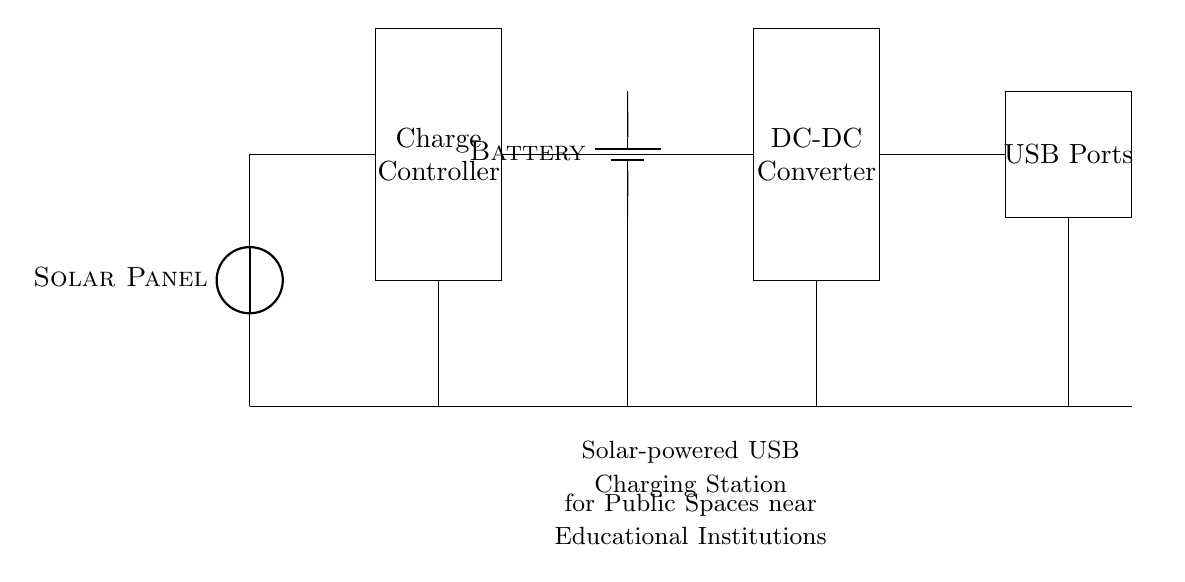What is the function of the solar panel? The solar panel converts solar energy into electrical energy, providing power to the circuit.
Answer: Converts solar energy What component stores electrical energy in this circuit? The component that stores electrical energy is the battery, which charges from the solar panel's output.
Answer: Battery How many USB ports are available in this circuit? The circuit shows two USB ports located at the end of the diagram, where devices can be connected for charging.
Answer: Two What is the role of the charge controller? The charge controller regulates the voltage and current going to the battery to ensure safe charging, preventing overcharging.
Answer: Regulates charging What type of converter is used in this solar-powered charging station? The diagram includes a DC-DC converter, which is responsible for adjusting the voltage to the appropriate level for the USB ports.
Answer: DC-DC converter Why is a DC-DC converter necessary in this circuit? A DC-DC converter is necessary to ensure that the voltage output for the USB ports is consistent (typically 5V) for safe charging of devices regardless of the battery level.
Answer: Ensures consistent voltage 